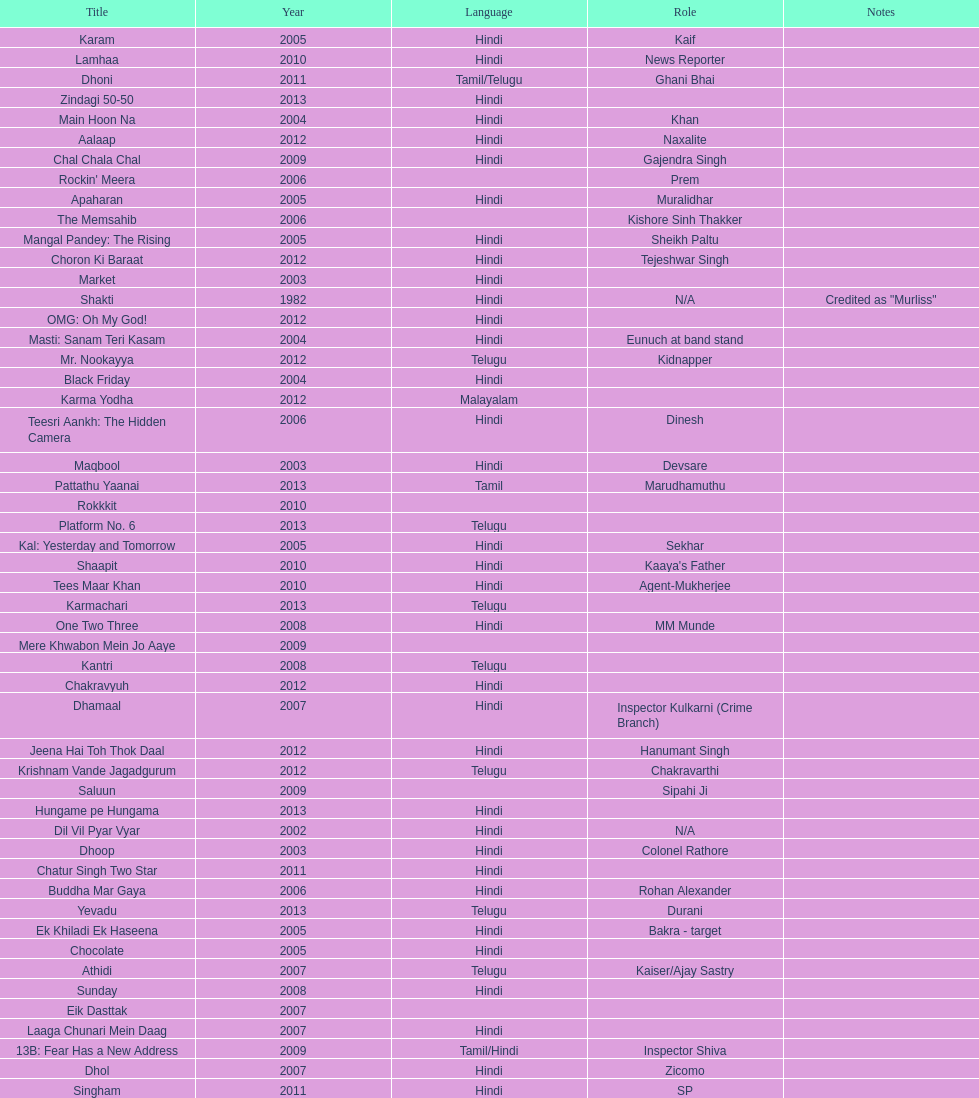What are the number of titles listed in 2005? 6. 